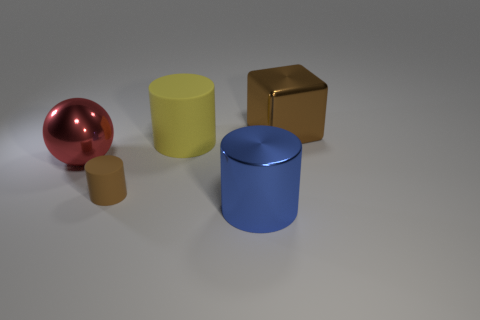How many matte cylinders are the same color as the big matte object?
Provide a succinct answer. 0. There is another large thing that is the same shape as the big blue metallic thing; what is its color?
Keep it short and to the point. Yellow. How many big blocks are behind the rubber cylinder that is right of the tiny rubber thing?
Make the answer very short. 1. How many cubes are large metallic things or brown shiny objects?
Make the answer very short. 1. Are any large cylinders visible?
Your answer should be very brief. Yes. What size is the blue metallic object that is the same shape as the large rubber thing?
Provide a short and direct response. Large. There is a metal thing that is to the right of the metal thing that is in front of the red object; what shape is it?
Ensure brevity in your answer.  Cube. How many cyan objects are either large blocks or big cylinders?
Your answer should be very brief. 0. What color is the metallic sphere?
Keep it short and to the point. Red. Do the blue thing and the brown metal cube have the same size?
Your answer should be compact. Yes. 